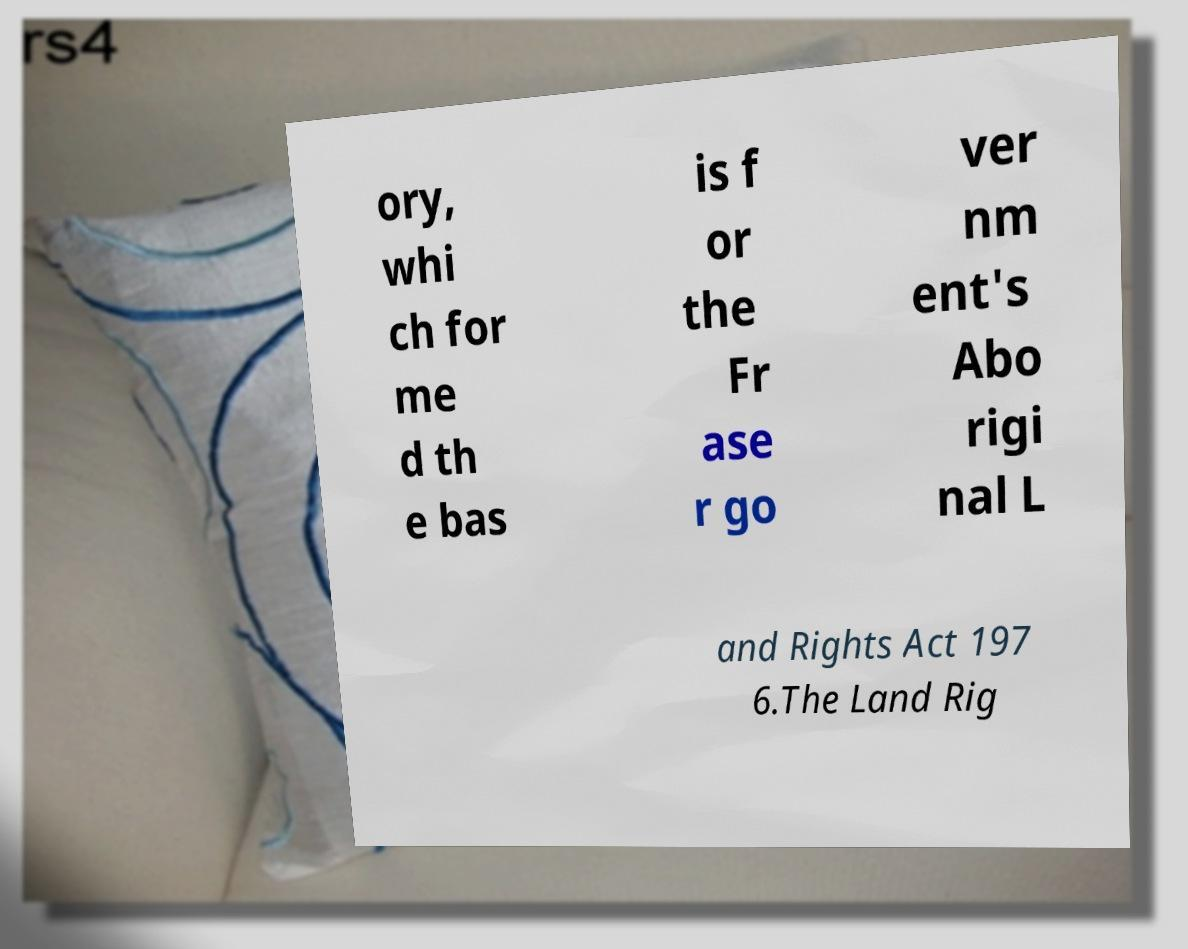Can you accurately transcribe the text from the provided image for me? ory, whi ch for me d th e bas is f or the Fr ase r go ver nm ent's Abo rigi nal L and Rights Act 197 6.The Land Rig 